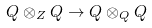<formula> <loc_0><loc_0><loc_500><loc_500>Q \otimes _ { Z } Q \rightarrow Q \otimes _ { Q } Q</formula> 